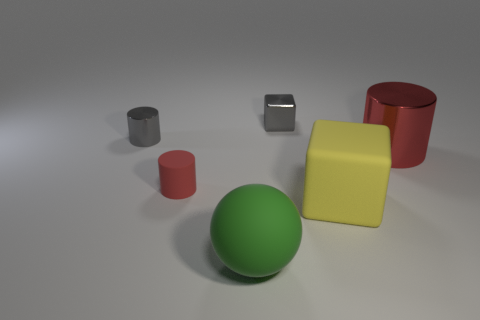Subtract all metallic cylinders. How many cylinders are left? 1 Add 2 metallic blocks. How many objects exist? 8 Subtract all gray cylinders. How many cylinders are left? 2 Subtract 1 spheres. How many spheres are left? 0 Subtract all balls. How many objects are left? 5 Add 3 big red shiny things. How many big red shiny things are left? 4 Add 1 metal cylinders. How many metal cylinders exist? 3 Subtract 0 green cylinders. How many objects are left? 6 Subtract all brown cylinders. Subtract all blue balls. How many cylinders are left? 3 Subtract all yellow blocks. How many gray cylinders are left? 1 